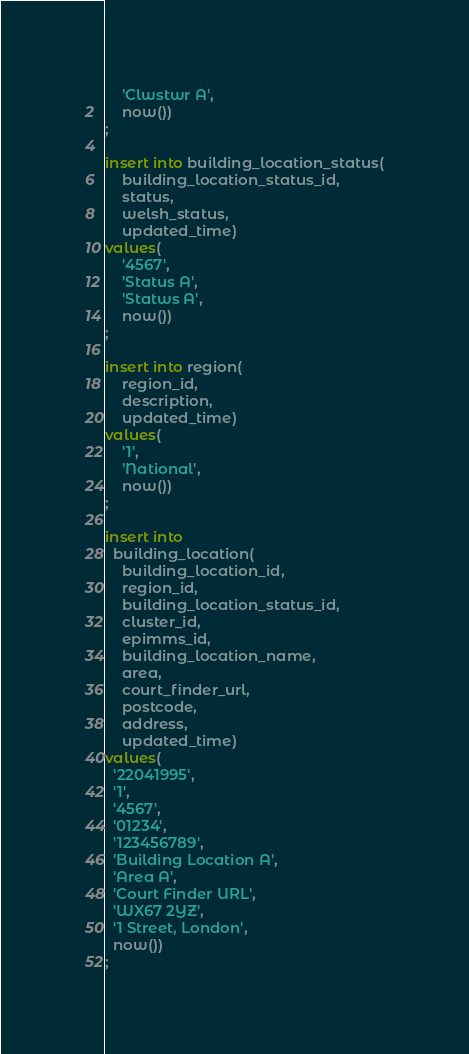<code> <loc_0><loc_0><loc_500><loc_500><_SQL_>    'Clwstwr A',
    now())
;

insert into building_location_status(
    building_location_status_id,
    status,
    welsh_status,
    updated_time)
values(
    '4567',
    'Status A',
    'Statws A',
    now())
;

insert into region(
    region_id,
    description,
    updated_time)
values(
    '1',
    'National',
    now())
;

insert into
  building_location(
    building_location_id,
    region_id,
    building_location_status_id,
    cluster_id,
    epimms_id,
    building_location_name,
    area,
    court_finder_url,
    postcode,
    address,
    updated_time)
values(
  '22041995',
  '1',
  '4567',
  '01234',
  '123456789',
  'Building Location A',
  'Area A',
  'Court Finder URL',
  'WX67 2YZ',
  '1 Street, London',
  now())
;
</code> 